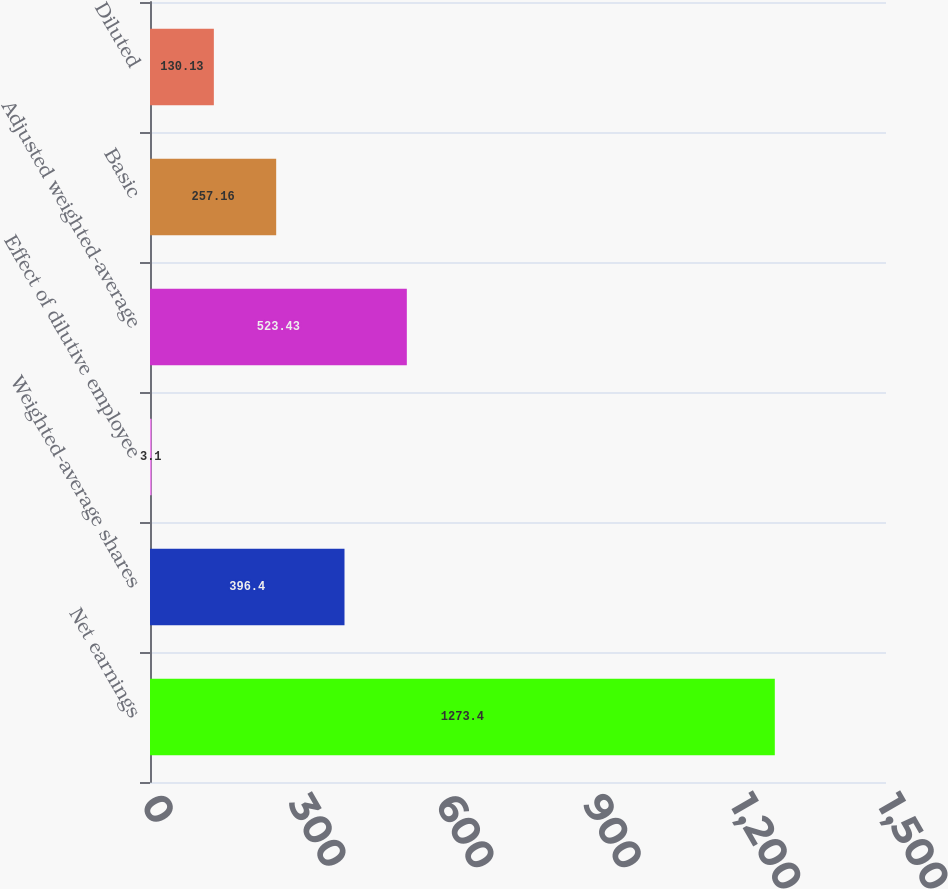<chart> <loc_0><loc_0><loc_500><loc_500><bar_chart><fcel>Net earnings<fcel>Weighted-average shares<fcel>Effect of dilutive employee<fcel>Adjusted weighted-average<fcel>Basic<fcel>Diluted<nl><fcel>1273.4<fcel>396.4<fcel>3.1<fcel>523.43<fcel>257.16<fcel>130.13<nl></chart> 